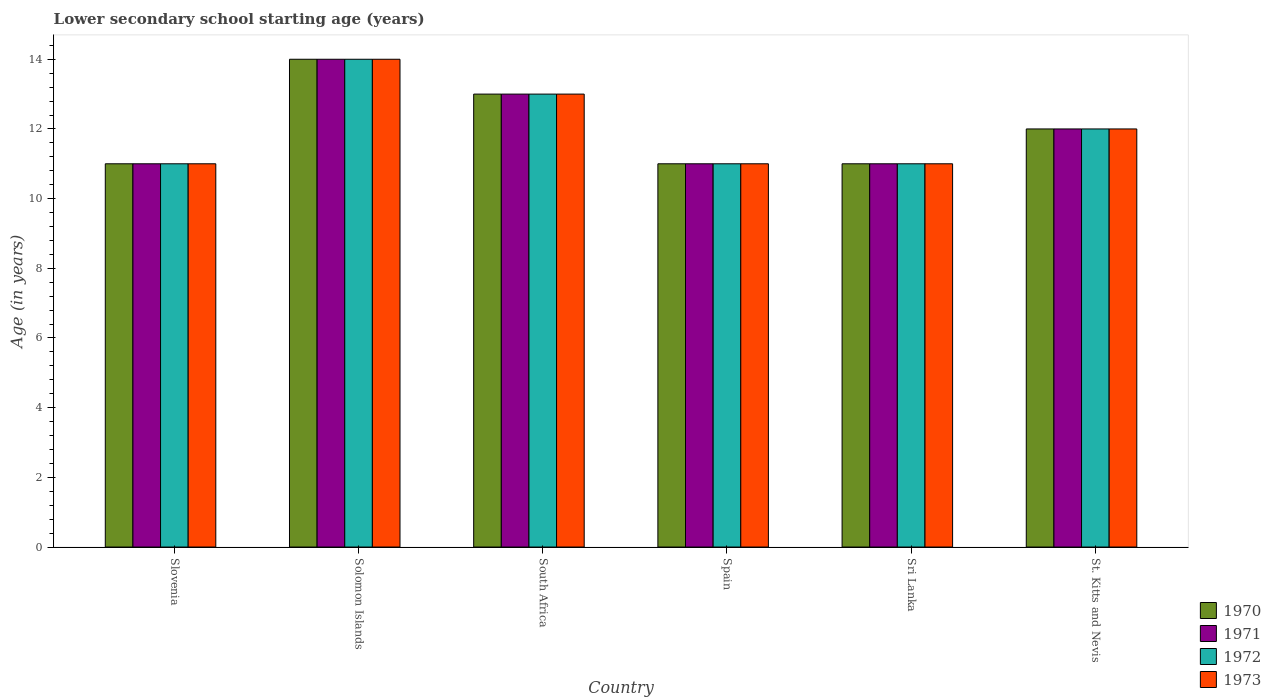Are the number of bars on each tick of the X-axis equal?
Your answer should be very brief. Yes. How many bars are there on the 2nd tick from the left?
Ensure brevity in your answer.  4. What is the label of the 2nd group of bars from the left?
Your response must be concise. Solomon Islands. In how many cases, is the number of bars for a given country not equal to the number of legend labels?
Offer a terse response. 0. What is the lower secondary school starting age of children in 1973 in Slovenia?
Your response must be concise. 11. In which country was the lower secondary school starting age of children in 1970 maximum?
Your response must be concise. Solomon Islands. In which country was the lower secondary school starting age of children in 1971 minimum?
Your answer should be compact. Slovenia. What is the difference between the lower secondary school starting age of children in 1971 in Slovenia and that in South Africa?
Your answer should be very brief. -2. What is the difference between the lower secondary school starting age of children in 1972 in Solomon Islands and the lower secondary school starting age of children in 1973 in Spain?
Offer a terse response. 3. What is the ratio of the lower secondary school starting age of children in 1971 in Solomon Islands to that in Sri Lanka?
Give a very brief answer. 1.27. Is the difference between the lower secondary school starting age of children in 1970 in South Africa and St. Kitts and Nevis greater than the difference between the lower secondary school starting age of children in 1972 in South Africa and St. Kitts and Nevis?
Provide a short and direct response. No. What is the difference between the highest and the lowest lower secondary school starting age of children in 1972?
Offer a terse response. 3. Is the sum of the lower secondary school starting age of children in 1971 in Spain and St. Kitts and Nevis greater than the maximum lower secondary school starting age of children in 1973 across all countries?
Give a very brief answer. Yes. Is it the case that in every country, the sum of the lower secondary school starting age of children in 1970 and lower secondary school starting age of children in 1971 is greater than the sum of lower secondary school starting age of children in 1973 and lower secondary school starting age of children in 1972?
Your answer should be very brief. No. What does the 2nd bar from the right in South Africa represents?
Offer a terse response. 1972. Is it the case that in every country, the sum of the lower secondary school starting age of children in 1973 and lower secondary school starting age of children in 1971 is greater than the lower secondary school starting age of children in 1972?
Your answer should be compact. Yes. How many bars are there?
Your response must be concise. 24. How many countries are there in the graph?
Keep it short and to the point. 6. What is the difference between two consecutive major ticks on the Y-axis?
Give a very brief answer. 2. Are the values on the major ticks of Y-axis written in scientific E-notation?
Offer a very short reply. No. How are the legend labels stacked?
Offer a terse response. Vertical. What is the title of the graph?
Ensure brevity in your answer.  Lower secondary school starting age (years). What is the label or title of the Y-axis?
Keep it short and to the point. Age (in years). What is the Age (in years) in 1970 in Slovenia?
Your answer should be very brief. 11. What is the Age (in years) of 1972 in Slovenia?
Offer a terse response. 11. What is the Age (in years) in 1973 in Slovenia?
Ensure brevity in your answer.  11. What is the Age (in years) in 1972 in Solomon Islands?
Provide a succinct answer. 14. What is the Age (in years) of 1973 in Solomon Islands?
Your answer should be compact. 14. What is the Age (in years) in 1971 in South Africa?
Provide a succinct answer. 13. What is the Age (in years) of 1972 in South Africa?
Your response must be concise. 13. What is the Age (in years) in 1973 in South Africa?
Offer a very short reply. 13. What is the Age (in years) of 1970 in Sri Lanka?
Make the answer very short. 11. What is the Age (in years) of 1971 in Sri Lanka?
Provide a short and direct response. 11. What is the Age (in years) of 1972 in Sri Lanka?
Give a very brief answer. 11. What is the Age (in years) of 1973 in Sri Lanka?
Provide a short and direct response. 11. What is the Age (in years) of 1970 in St. Kitts and Nevis?
Give a very brief answer. 12. What is the Age (in years) in 1971 in St. Kitts and Nevis?
Offer a very short reply. 12. Across all countries, what is the maximum Age (in years) in 1971?
Offer a terse response. 14. Across all countries, what is the maximum Age (in years) in 1972?
Ensure brevity in your answer.  14. Across all countries, what is the maximum Age (in years) in 1973?
Your answer should be very brief. 14. Across all countries, what is the minimum Age (in years) in 1972?
Provide a short and direct response. 11. Across all countries, what is the minimum Age (in years) of 1973?
Your response must be concise. 11. What is the total Age (in years) in 1971 in the graph?
Ensure brevity in your answer.  72. What is the difference between the Age (in years) in 1970 in Slovenia and that in South Africa?
Your answer should be compact. -2. What is the difference between the Age (in years) in 1971 in Slovenia and that in South Africa?
Your answer should be very brief. -2. What is the difference between the Age (in years) in 1973 in Slovenia and that in Sri Lanka?
Your response must be concise. 0. What is the difference between the Age (in years) in 1970 in Slovenia and that in St. Kitts and Nevis?
Your response must be concise. -1. What is the difference between the Age (in years) in 1972 in Slovenia and that in St. Kitts and Nevis?
Your answer should be very brief. -1. What is the difference between the Age (in years) in 1973 in Slovenia and that in St. Kitts and Nevis?
Make the answer very short. -1. What is the difference between the Age (in years) of 1973 in Solomon Islands and that in South Africa?
Your answer should be compact. 1. What is the difference between the Age (in years) in 1972 in Solomon Islands and that in Spain?
Your answer should be compact. 3. What is the difference between the Age (in years) in 1973 in Solomon Islands and that in Spain?
Make the answer very short. 3. What is the difference between the Age (in years) in 1971 in Solomon Islands and that in Sri Lanka?
Give a very brief answer. 3. What is the difference between the Age (in years) of 1972 in Solomon Islands and that in Sri Lanka?
Keep it short and to the point. 3. What is the difference between the Age (in years) of 1973 in Solomon Islands and that in Sri Lanka?
Make the answer very short. 3. What is the difference between the Age (in years) in 1970 in Solomon Islands and that in St. Kitts and Nevis?
Provide a succinct answer. 2. What is the difference between the Age (in years) of 1971 in South Africa and that in Spain?
Keep it short and to the point. 2. What is the difference between the Age (in years) of 1971 in South Africa and that in Sri Lanka?
Provide a short and direct response. 2. What is the difference between the Age (in years) of 1972 in South Africa and that in Sri Lanka?
Offer a very short reply. 2. What is the difference between the Age (in years) of 1971 in South Africa and that in St. Kitts and Nevis?
Give a very brief answer. 1. What is the difference between the Age (in years) in 1972 in South Africa and that in St. Kitts and Nevis?
Keep it short and to the point. 1. What is the difference between the Age (in years) of 1970 in Spain and that in Sri Lanka?
Offer a terse response. 0. What is the difference between the Age (in years) of 1972 in Spain and that in Sri Lanka?
Your response must be concise. 0. What is the difference between the Age (in years) in 1973 in Spain and that in Sri Lanka?
Your answer should be compact. 0. What is the difference between the Age (in years) in 1973 in Spain and that in St. Kitts and Nevis?
Provide a succinct answer. -1. What is the difference between the Age (in years) of 1970 in Slovenia and the Age (in years) of 1971 in Solomon Islands?
Your answer should be compact. -3. What is the difference between the Age (in years) of 1971 in Slovenia and the Age (in years) of 1973 in South Africa?
Offer a very short reply. -2. What is the difference between the Age (in years) of 1972 in Slovenia and the Age (in years) of 1973 in South Africa?
Offer a very short reply. -2. What is the difference between the Age (in years) in 1970 in Slovenia and the Age (in years) in 1971 in Spain?
Provide a succinct answer. 0. What is the difference between the Age (in years) of 1970 in Slovenia and the Age (in years) of 1972 in Spain?
Keep it short and to the point. 0. What is the difference between the Age (in years) of 1971 in Slovenia and the Age (in years) of 1972 in Spain?
Provide a short and direct response. 0. What is the difference between the Age (in years) in 1971 in Slovenia and the Age (in years) in 1973 in Spain?
Offer a very short reply. 0. What is the difference between the Age (in years) of 1972 in Slovenia and the Age (in years) of 1973 in Spain?
Your answer should be compact. 0. What is the difference between the Age (in years) in 1970 in Slovenia and the Age (in years) in 1972 in Sri Lanka?
Your answer should be very brief. 0. What is the difference between the Age (in years) in 1972 in Slovenia and the Age (in years) in 1973 in Sri Lanka?
Provide a short and direct response. 0. What is the difference between the Age (in years) in 1970 in Slovenia and the Age (in years) in 1973 in St. Kitts and Nevis?
Offer a terse response. -1. What is the difference between the Age (in years) in 1972 in Slovenia and the Age (in years) in 1973 in St. Kitts and Nevis?
Provide a short and direct response. -1. What is the difference between the Age (in years) in 1970 in Solomon Islands and the Age (in years) in 1971 in South Africa?
Make the answer very short. 1. What is the difference between the Age (in years) of 1971 in Solomon Islands and the Age (in years) of 1972 in South Africa?
Provide a succinct answer. 1. What is the difference between the Age (in years) of 1971 in Solomon Islands and the Age (in years) of 1973 in Spain?
Offer a terse response. 3. What is the difference between the Age (in years) in 1972 in Solomon Islands and the Age (in years) in 1973 in Spain?
Provide a succinct answer. 3. What is the difference between the Age (in years) in 1970 in Solomon Islands and the Age (in years) in 1971 in Sri Lanka?
Your response must be concise. 3. What is the difference between the Age (in years) in 1970 in Solomon Islands and the Age (in years) in 1972 in Sri Lanka?
Your answer should be compact. 3. What is the difference between the Age (in years) in 1971 in Solomon Islands and the Age (in years) in 1972 in Sri Lanka?
Your answer should be compact. 3. What is the difference between the Age (in years) of 1970 in Solomon Islands and the Age (in years) of 1971 in St. Kitts and Nevis?
Offer a terse response. 2. What is the difference between the Age (in years) in 1970 in Solomon Islands and the Age (in years) in 1973 in St. Kitts and Nevis?
Make the answer very short. 2. What is the difference between the Age (in years) of 1971 in Solomon Islands and the Age (in years) of 1972 in St. Kitts and Nevis?
Your response must be concise. 2. What is the difference between the Age (in years) of 1971 in Solomon Islands and the Age (in years) of 1973 in St. Kitts and Nevis?
Ensure brevity in your answer.  2. What is the difference between the Age (in years) of 1970 in South Africa and the Age (in years) of 1973 in Spain?
Offer a terse response. 2. What is the difference between the Age (in years) of 1971 in South Africa and the Age (in years) of 1972 in Spain?
Provide a short and direct response. 2. What is the difference between the Age (in years) of 1971 in South Africa and the Age (in years) of 1973 in Spain?
Offer a terse response. 2. What is the difference between the Age (in years) of 1972 in South Africa and the Age (in years) of 1973 in Spain?
Your answer should be very brief. 2. What is the difference between the Age (in years) of 1970 in South Africa and the Age (in years) of 1972 in Sri Lanka?
Offer a very short reply. 2. What is the difference between the Age (in years) in 1970 in South Africa and the Age (in years) in 1973 in Sri Lanka?
Offer a very short reply. 2. What is the difference between the Age (in years) of 1971 in South Africa and the Age (in years) of 1972 in Sri Lanka?
Give a very brief answer. 2. What is the difference between the Age (in years) in 1971 in South Africa and the Age (in years) in 1973 in Sri Lanka?
Provide a succinct answer. 2. What is the difference between the Age (in years) of 1972 in South Africa and the Age (in years) of 1973 in Sri Lanka?
Make the answer very short. 2. What is the difference between the Age (in years) of 1970 in South Africa and the Age (in years) of 1971 in St. Kitts and Nevis?
Make the answer very short. 1. What is the difference between the Age (in years) of 1970 in South Africa and the Age (in years) of 1972 in St. Kitts and Nevis?
Make the answer very short. 1. What is the difference between the Age (in years) of 1971 in South Africa and the Age (in years) of 1972 in St. Kitts and Nevis?
Offer a very short reply. 1. What is the difference between the Age (in years) in 1972 in South Africa and the Age (in years) in 1973 in St. Kitts and Nevis?
Ensure brevity in your answer.  1. What is the difference between the Age (in years) in 1970 in Spain and the Age (in years) in 1971 in Sri Lanka?
Ensure brevity in your answer.  0. What is the difference between the Age (in years) in 1970 in Spain and the Age (in years) in 1972 in Sri Lanka?
Provide a succinct answer. 0. What is the difference between the Age (in years) of 1971 in Spain and the Age (in years) of 1972 in Sri Lanka?
Give a very brief answer. 0. What is the difference between the Age (in years) in 1970 in Spain and the Age (in years) in 1972 in St. Kitts and Nevis?
Make the answer very short. -1. What is the difference between the Age (in years) in 1970 in Spain and the Age (in years) in 1973 in St. Kitts and Nevis?
Your response must be concise. -1. What is the difference between the Age (in years) of 1971 in Spain and the Age (in years) of 1972 in St. Kitts and Nevis?
Your answer should be very brief. -1. What is the difference between the Age (in years) in 1972 in Spain and the Age (in years) in 1973 in St. Kitts and Nevis?
Offer a very short reply. -1. What is the difference between the Age (in years) in 1970 in Sri Lanka and the Age (in years) in 1971 in St. Kitts and Nevis?
Offer a terse response. -1. What is the difference between the Age (in years) of 1970 in Sri Lanka and the Age (in years) of 1972 in St. Kitts and Nevis?
Ensure brevity in your answer.  -1. What is the difference between the Age (in years) in 1971 in Sri Lanka and the Age (in years) in 1972 in St. Kitts and Nevis?
Provide a succinct answer. -1. What is the average Age (in years) of 1970 per country?
Offer a very short reply. 12. What is the average Age (in years) of 1972 per country?
Your answer should be compact. 12. What is the difference between the Age (in years) in 1970 and Age (in years) in 1971 in Slovenia?
Keep it short and to the point. 0. What is the difference between the Age (in years) of 1970 and Age (in years) of 1972 in Slovenia?
Your response must be concise. 0. What is the difference between the Age (in years) of 1970 and Age (in years) of 1973 in Slovenia?
Keep it short and to the point. 0. What is the difference between the Age (in years) of 1971 and Age (in years) of 1972 in Slovenia?
Your answer should be very brief. 0. What is the difference between the Age (in years) of 1971 and Age (in years) of 1973 in Slovenia?
Provide a short and direct response. 0. What is the difference between the Age (in years) in 1972 and Age (in years) in 1973 in Slovenia?
Your response must be concise. 0. What is the difference between the Age (in years) of 1970 and Age (in years) of 1972 in Solomon Islands?
Your answer should be very brief. 0. What is the difference between the Age (in years) of 1970 and Age (in years) of 1973 in Solomon Islands?
Your answer should be very brief. 0. What is the difference between the Age (in years) in 1970 and Age (in years) in 1971 in South Africa?
Offer a very short reply. 0. What is the difference between the Age (in years) in 1971 and Age (in years) in 1972 in South Africa?
Offer a very short reply. 0. What is the difference between the Age (in years) of 1970 and Age (in years) of 1971 in Spain?
Offer a very short reply. 0. What is the difference between the Age (in years) in 1970 and Age (in years) in 1973 in Spain?
Give a very brief answer. 0. What is the difference between the Age (in years) of 1971 and Age (in years) of 1972 in Spain?
Ensure brevity in your answer.  0. What is the difference between the Age (in years) of 1971 and Age (in years) of 1972 in Sri Lanka?
Provide a short and direct response. 0. What is the difference between the Age (in years) in 1971 and Age (in years) in 1973 in Sri Lanka?
Keep it short and to the point. 0. What is the difference between the Age (in years) of 1972 and Age (in years) of 1973 in Sri Lanka?
Your answer should be very brief. 0. What is the difference between the Age (in years) of 1971 and Age (in years) of 1973 in St. Kitts and Nevis?
Your response must be concise. 0. What is the difference between the Age (in years) of 1972 and Age (in years) of 1973 in St. Kitts and Nevis?
Your response must be concise. 0. What is the ratio of the Age (in years) of 1970 in Slovenia to that in Solomon Islands?
Your answer should be compact. 0.79. What is the ratio of the Age (in years) in 1971 in Slovenia to that in Solomon Islands?
Give a very brief answer. 0.79. What is the ratio of the Age (in years) in 1972 in Slovenia to that in Solomon Islands?
Your answer should be compact. 0.79. What is the ratio of the Age (in years) in 1973 in Slovenia to that in Solomon Islands?
Offer a very short reply. 0.79. What is the ratio of the Age (in years) in 1970 in Slovenia to that in South Africa?
Ensure brevity in your answer.  0.85. What is the ratio of the Age (in years) of 1971 in Slovenia to that in South Africa?
Provide a succinct answer. 0.85. What is the ratio of the Age (in years) of 1972 in Slovenia to that in South Africa?
Offer a terse response. 0.85. What is the ratio of the Age (in years) of 1973 in Slovenia to that in South Africa?
Keep it short and to the point. 0.85. What is the ratio of the Age (in years) of 1971 in Slovenia to that in Spain?
Your response must be concise. 1. What is the ratio of the Age (in years) of 1972 in Slovenia to that in Spain?
Your answer should be compact. 1. What is the ratio of the Age (in years) in 1973 in Slovenia to that in Spain?
Offer a very short reply. 1. What is the ratio of the Age (in years) of 1970 in Slovenia to that in Sri Lanka?
Give a very brief answer. 1. What is the ratio of the Age (in years) in 1972 in Slovenia to that in Sri Lanka?
Your answer should be very brief. 1. What is the ratio of the Age (in years) in 1971 in Slovenia to that in St. Kitts and Nevis?
Your response must be concise. 0.92. What is the ratio of the Age (in years) in 1973 in Slovenia to that in St. Kitts and Nevis?
Provide a succinct answer. 0.92. What is the ratio of the Age (in years) of 1970 in Solomon Islands to that in South Africa?
Provide a succinct answer. 1.08. What is the ratio of the Age (in years) in 1972 in Solomon Islands to that in South Africa?
Give a very brief answer. 1.08. What is the ratio of the Age (in years) of 1973 in Solomon Islands to that in South Africa?
Offer a terse response. 1.08. What is the ratio of the Age (in years) in 1970 in Solomon Islands to that in Spain?
Give a very brief answer. 1.27. What is the ratio of the Age (in years) of 1971 in Solomon Islands to that in Spain?
Keep it short and to the point. 1.27. What is the ratio of the Age (in years) in 1972 in Solomon Islands to that in Spain?
Give a very brief answer. 1.27. What is the ratio of the Age (in years) of 1973 in Solomon Islands to that in Spain?
Give a very brief answer. 1.27. What is the ratio of the Age (in years) in 1970 in Solomon Islands to that in Sri Lanka?
Offer a terse response. 1.27. What is the ratio of the Age (in years) of 1971 in Solomon Islands to that in Sri Lanka?
Your answer should be compact. 1.27. What is the ratio of the Age (in years) of 1972 in Solomon Islands to that in Sri Lanka?
Provide a short and direct response. 1.27. What is the ratio of the Age (in years) of 1973 in Solomon Islands to that in Sri Lanka?
Offer a terse response. 1.27. What is the ratio of the Age (in years) of 1971 in Solomon Islands to that in St. Kitts and Nevis?
Ensure brevity in your answer.  1.17. What is the ratio of the Age (in years) in 1973 in Solomon Islands to that in St. Kitts and Nevis?
Provide a short and direct response. 1.17. What is the ratio of the Age (in years) in 1970 in South Africa to that in Spain?
Provide a short and direct response. 1.18. What is the ratio of the Age (in years) of 1971 in South Africa to that in Spain?
Your response must be concise. 1.18. What is the ratio of the Age (in years) in 1972 in South Africa to that in Spain?
Offer a terse response. 1.18. What is the ratio of the Age (in years) of 1973 in South Africa to that in Spain?
Offer a very short reply. 1.18. What is the ratio of the Age (in years) in 1970 in South Africa to that in Sri Lanka?
Provide a short and direct response. 1.18. What is the ratio of the Age (in years) in 1971 in South Africa to that in Sri Lanka?
Offer a very short reply. 1.18. What is the ratio of the Age (in years) of 1972 in South Africa to that in Sri Lanka?
Ensure brevity in your answer.  1.18. What is the ratio of the Age (in years) in 1973 in South Africa to that in Sri Lanka?
Offer a terse response. 1.18. What is the ratio of the Age (in years) in 1970 in South Africa to that in St. Kitts and Nevis?
Provide a succinct answer. 1.08. What is the ratio of the Age (in years) of 1970 in Spain to that in St. Kitts and Nevis?
Provide a succinct answer. 0.92. What is the ratio of the Age (in years) in 1973 in Spain to that in St. Kitts and Nevis?
Give a very brief answer. 0.92. What is the ratio of the Age (in years) of 1970 in Sri Lanka to that in St. Kitts and Nevis?
Give a very brief answer. 0.92. What is the ratio of the Age (in years) in 1973 in Sri Lanka to that in St. Kitts and Nevis?
Your answer should be compact. 0.92. What is the difference between the highest and the second highest Age (in years) in 1970?
Your answer should be very brief. 1. What is the difference between the highest and the lowest Age (in years) of 1970?
Make the answer very short. 3. What is the difference between the highest and the lowest Age (in years) in 1973?
Give a very brief answer. 3. 